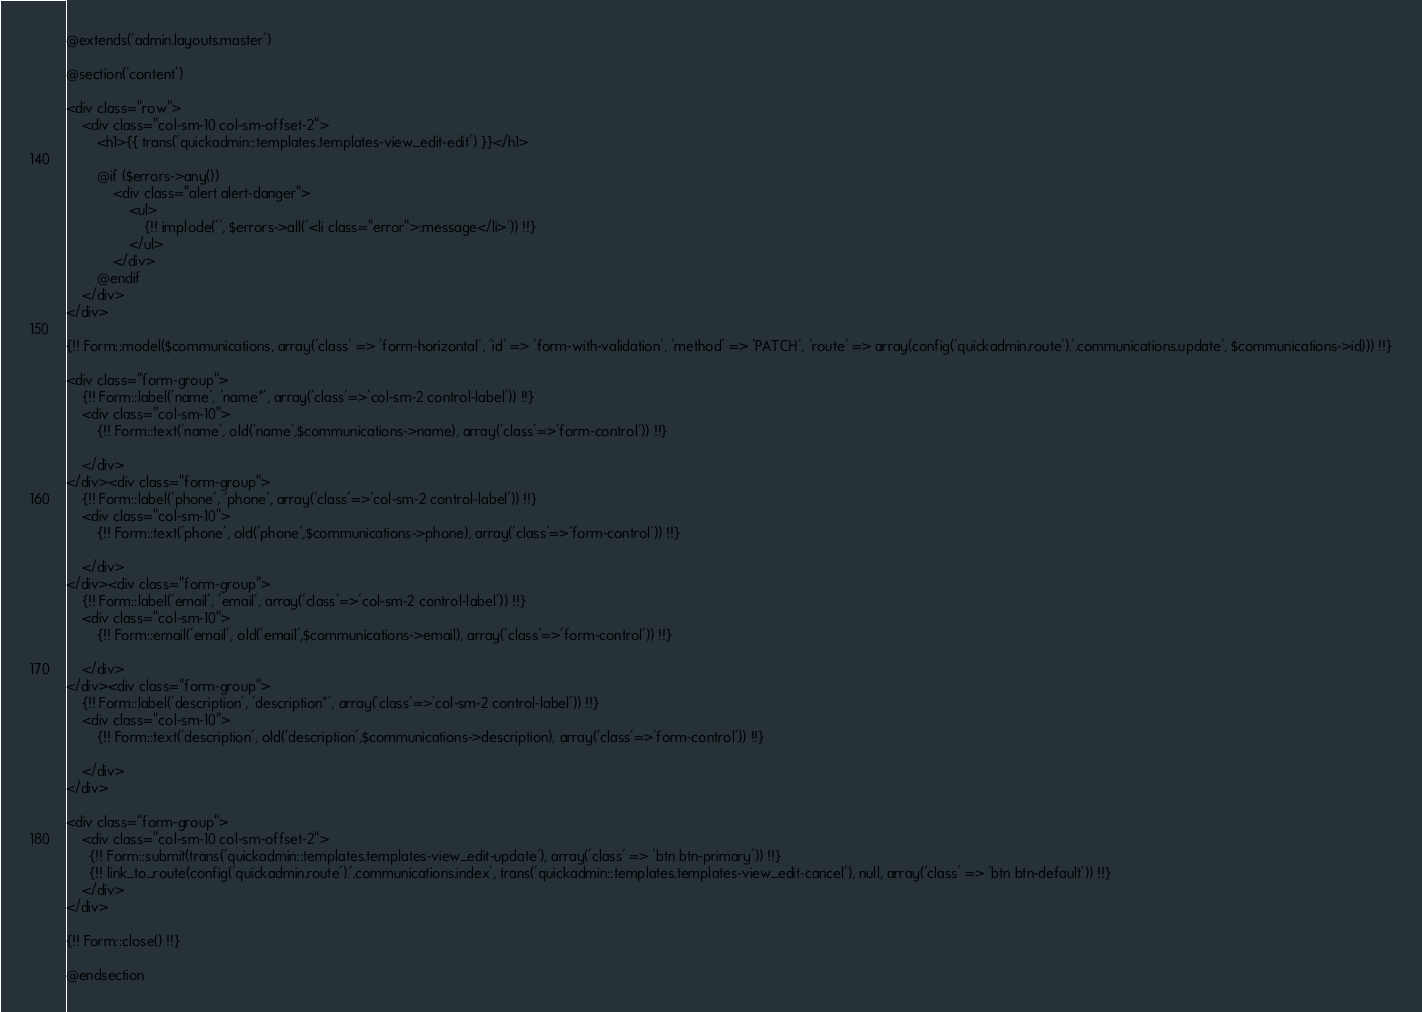Convert code to text. <code><loc_0><loc_0><loc_500><loc_500><_PHP_>@extends('admin.layouts.master')

@section('content')

<div class="row">
    <div class="col-sm-10 col-sm-offset-2">
        <h1>{{ trans('quickadmin::templates.templates-view_edit-edit') }}</h1>

        @if ($errors->any())
        	<div class="alert alert-danger">
        	    <ul>
                    {!! implode('', $errors->all('<li class="error">:message</li>')) !!}
                </ul>
        	</div>
        @endif
    </div>
</div>

{!! Form::model($communications, array('class' => 'form-horizontal', 'id' => 'form-with-validation', 'method' => 'PATCH', 'route' => array(config('quickadmin.route').'.communications.update', $communications->id))) !!}

<div class="form-group">
    {!! Form::label('name', 'name*', array('class'=>'col-sm-2 control-label')) !!}
    <div class="col-sm-10">
        {!! Form::text('name', old('name',$communications->name), array('class'=>'form-control')) !!}
        
    </div>
</div><div class="form-group">
    {!! Form::label('phone', 'phone', array('class'=>'col-sm-2 control-label')) !!}
    <div class="col-sm-10">
        {!! Form::text('phone', old('phone',$communications->phone), array('class'=>'form-control')) !!}
        
    </div>
</div><div class="form-group">
    {!! Form::label('email', 'email', array('class'=>'col-sm-2 control-label')) !!}
    <div class="col-sm-10">
        {!! Form::email('email', old('email',$communications->email), array('class'=>'form-control')) !!}
        
    </div>
</div><div class="form-group">
    {!! Form::label('description', 'description*', array('class'=>'col-sm-2 control-label')) !!}
    <div class="col-sm-10">
        {!! Form::text('description', old('description',$communications->description), array('class'=>'form-control')) !!}
        
    </div>
</div>

<div class="form-group">
    <div class="col-sm-10 col-sm-offset-2">
      {!! Form::submit(trans('quickadmin::templates.templates-view_edit-update'), array('class' => 'btn btn-primary')) !!}
      {!! link_to_route(config('quickadmin.route').'.communications.index', trans('quickadmin::templates.templates-view_edit-cancel'), null, array('class' => 'btn btn-default')) !!}
    </div>
</div>

{!! Form::close() !!}

@endsection</code> 